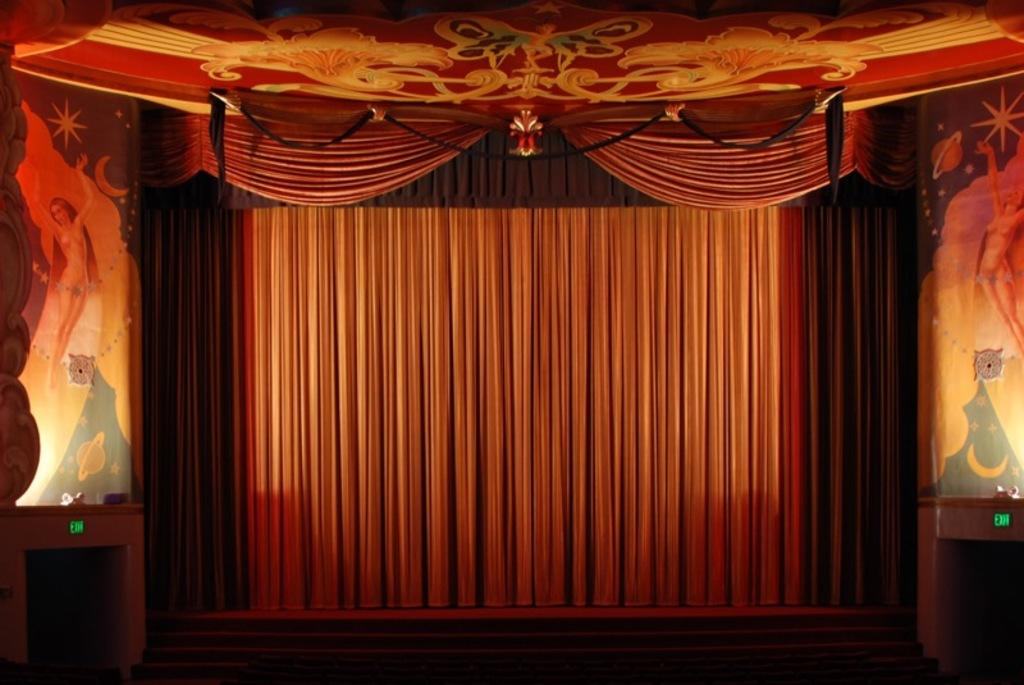What type of window treatment is visible in the image? There are curtains in the image. What type of structure can be seen in the background of the image? There is a wall in the image. How many daughters are present in the image? There is no mention of a daughter or any people in the image; it only features curtains and a wall. 